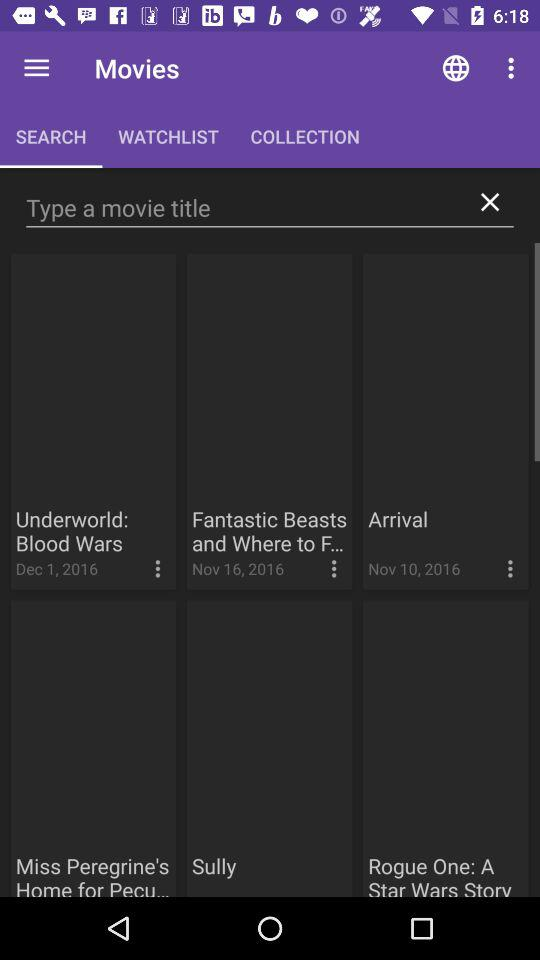What are the available movies? The available movies are "Underworld: Blood Wars", "Fantastic Beasts and Where to F...", "Arrival", "Miss Peregrine's Home for Pecu...", "Sully" and "Rogue One: A Star Wars Story". 